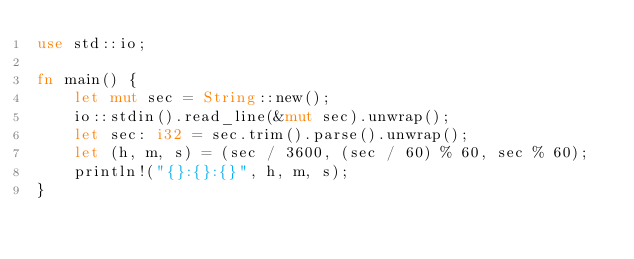Convert code to text. <code><loc_0><loc_0><loc_500><loc_500><_Rust_>use std::io;

fn main() {
    let mut sec = String::new();
    io::stdin().read_line(&mut sec).unwrap();
    let sec: i32 = sec.trim().parse().unwrap();
    let (h, m, s) = (sec / 3600, (sec / 60) % 60, sec % 60);
    println!("{}:{}:{}", h, m, s);
}

</code> 